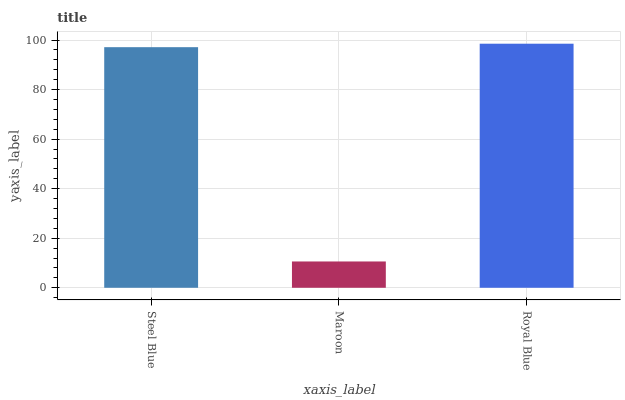Is Maroon the minimum?
Answer yes or no. Yes. Is Royal Blue the maximum?
Answer yes or no. Yes. Is Royal Blue the minimum?
Answer yes or no. No. Is Maroon the maximum?
Answer yes or no. No. Is Royal Blue greater than Maroon?
Answer yes or no. Yes. Is Maroon less than Royal Blue?
Answer yes or no. Yes. Is Maroon greater than Royal Blue?
Answer yes or no. No. Is Royal Blue less than Maroon?
Answer yes or no. No. Is Steel Blue the high median?
Answer yes or no. Yes. Is Steel Blue the low median?
Answer yes or no. Yes. Is Royal Blue the high median?
Answer yes or no. No. Is Royal Blue the low median?
Answer yes or no. No. 